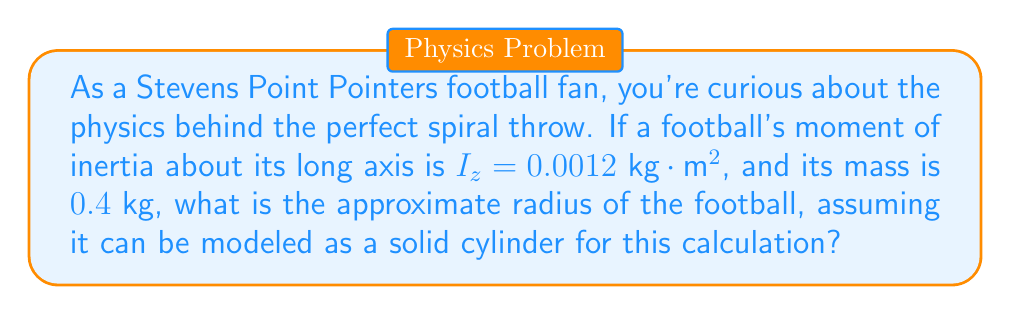Show me your answer to this math problem. Let's approach this step-by-step:

1) For a solid cylinder, the moment of inertia about its long axis is given by:

   $$I_z = \frac{1}{2}mr^2$$

   where $m$ is the mass and $r$ is the radius.

2) We're given:
   $I_z = 0.0012 \text{ kg}\cdot\text{m}^2$
   $m = 0.4 \text{ kg}$

3) Let's substitute these into our equation:

   $$0.0012 = \frac{1}{2} \cdot 0.4 \cdot r^2$$

4) Simplify:
   $$0.0012 = 0.2r^2$$

5) Divide both sides by 0.2:
   $$0.006 = r^2$$

6) Take the square root of both sides:
   $$r = \sqrt{0.006} \approx 0.0775 \text{ m}$$

7) Convert to centimeters:
   $$r \approx 7.75 \text{ cm}$$

This radius is a reasonable approximation for a football, which typically has a diameter of about 17-18 cm at its widest point.
Answer: $7.75 \text{ cm}$ 